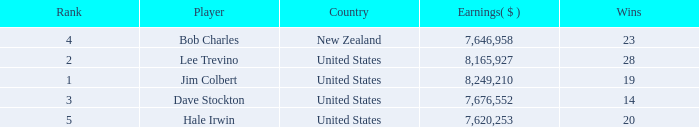How many average wins for players ranked below 2 with earnings greater than $7,676,552? None. 